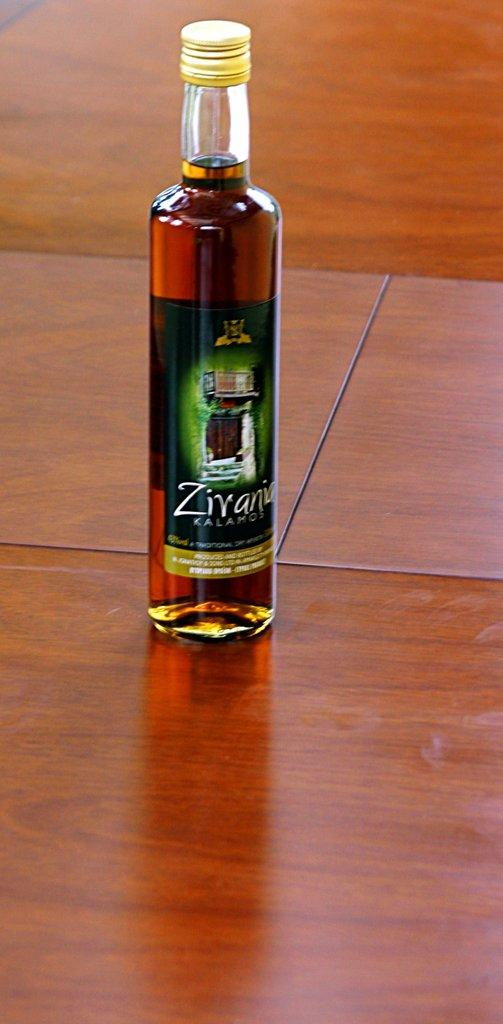<image>
Summarize the visual content of the image. A full bottle of Zivania Kalamos brandy is sitting on a wooden table. 